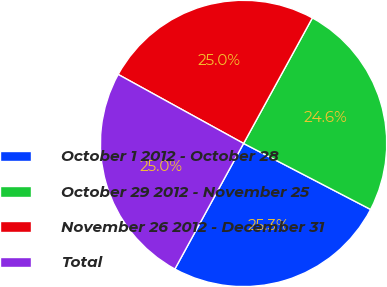Convert chart to OTSL. <chart><loc_0><loc_0><loc_500><loc_500><pie_chart><fcel>October 1 2012 - October 28<fcel>October 29 2012 - November 25<fcel>November 26 2012 - December 31<fcel>Total<nl><fcel>25.34%<fcel>24.65%<fcel>24.97%<fcel>25.04%<nl></chart> 